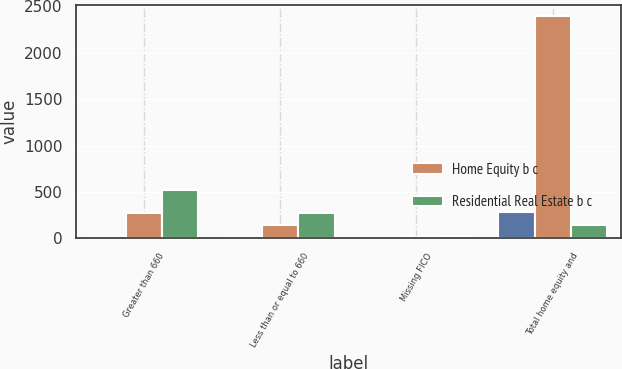Convert chart to OTSL. <chart><loc_0><loc_0><loc_500><loc_500><stacked_bar_chart><ecel><fcel>Greater than 660<fcel>Less than or equal to 660<fcel>Missing FICO<fcel>Total home equity and<nl><fcel>nan<fcel>8<fcel>9<fcel>1<fcel>282<nl><fcel>Home Equity b c<fcel>276<fcel>144<fcel>15<fcel>2396<nl><fcel>Residential Real Estate b c<fcel>527<fcel>278<fcel>28<fcel>144<nl></chart> 